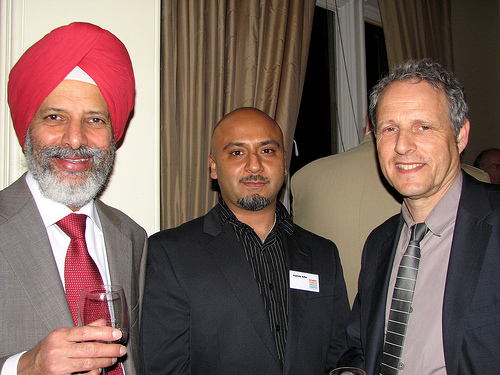<image>
Is the name tag on the curtain? No. The name tag is not positioned on the curtain. They may be near each other, but the name tag is not supported by or resting on top of the curtain. Where is the man in relation to the window? Is it behind the window? No. The man is not behind the window. From this viewpoint, the man appears to be positioned elsewhere in the scene. 